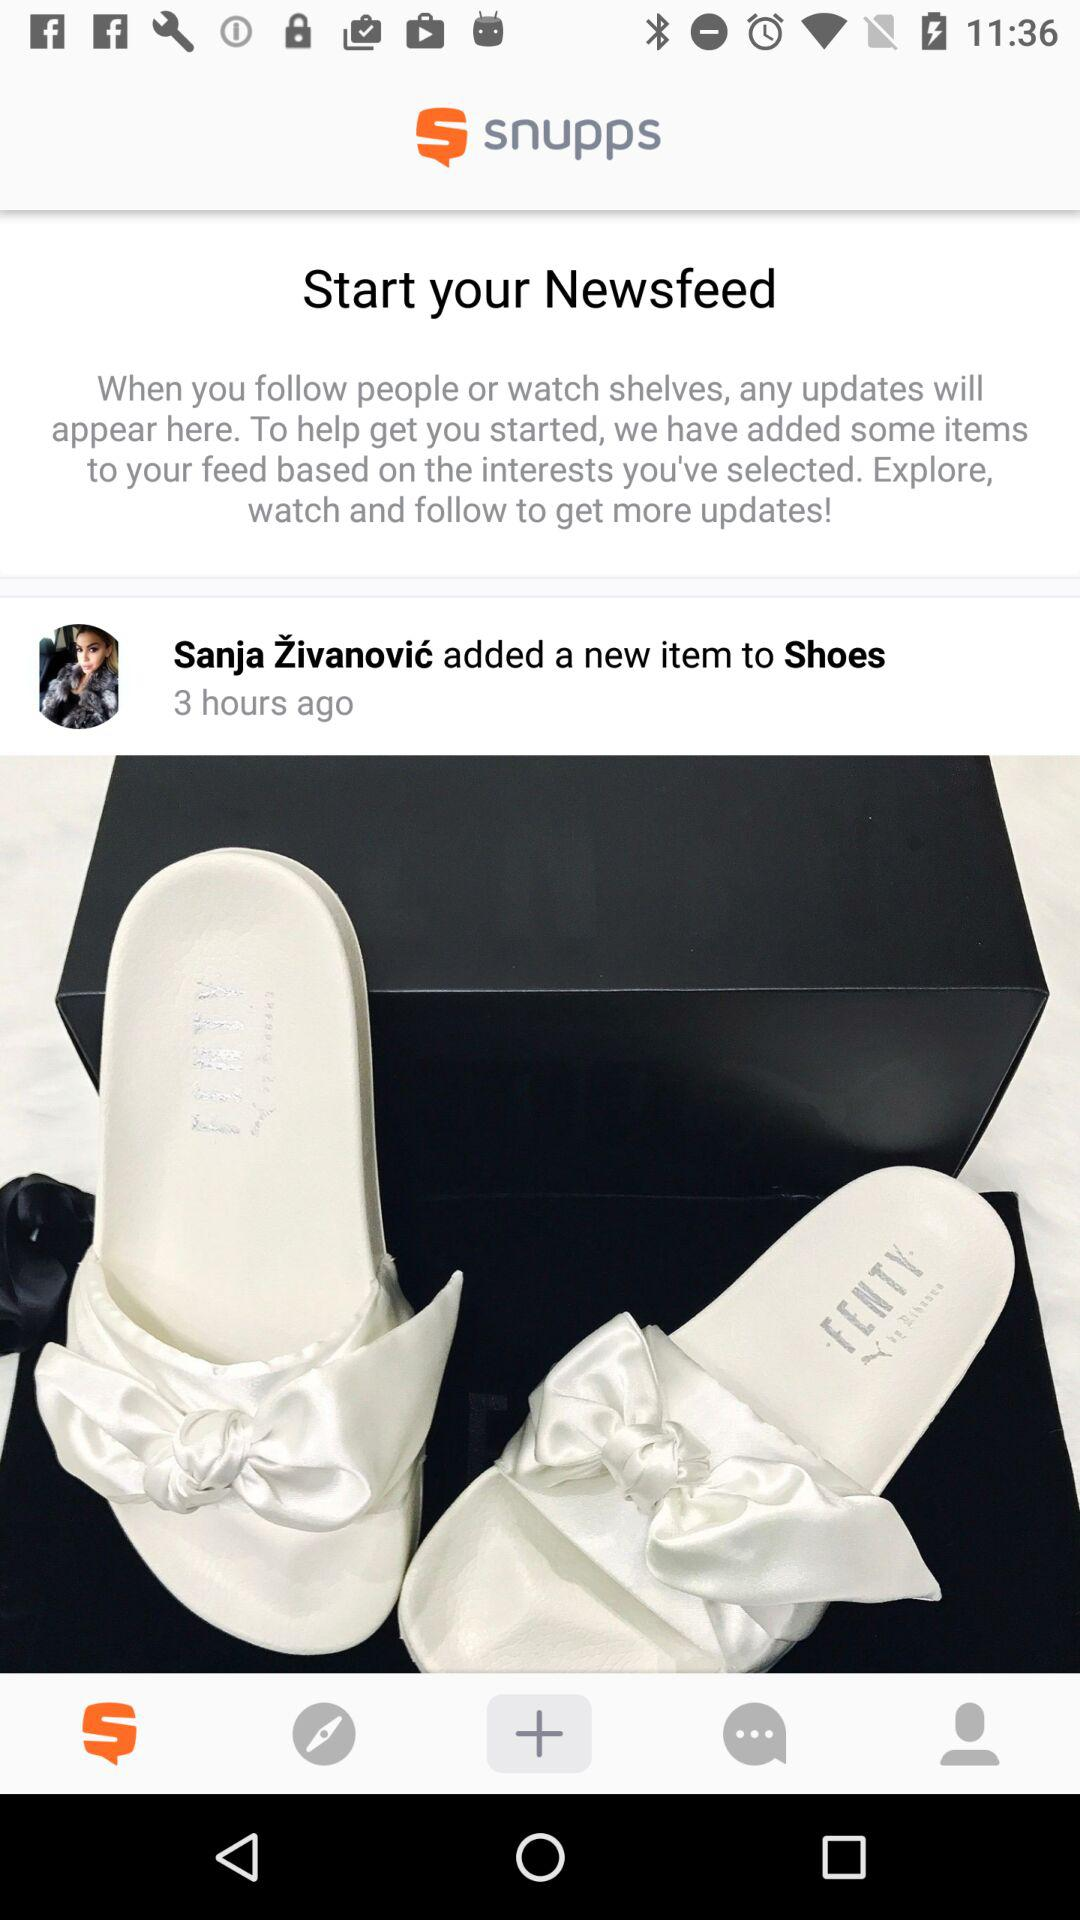How many items are in the user's feed?
Answer the question using a single word or phrase. 1 